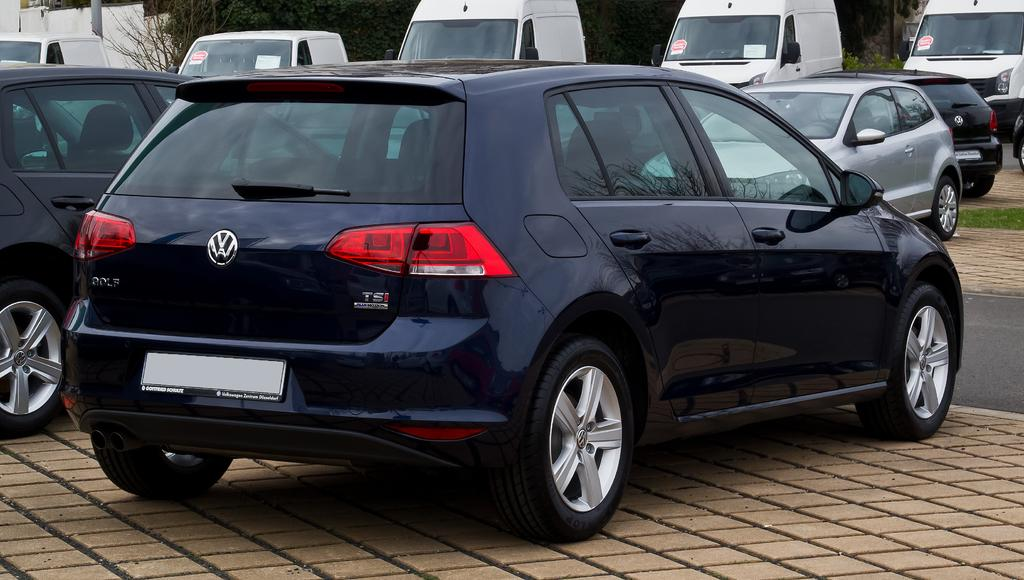What is the main subject of the image? The main subject of the image is many cars. Can you describe the position of a specific car in the image? A black car is parked on the pavement in the front. What can be seen on the right side of the image? There is a road on the right side of the image. What is visible in the background of the image? There are trees and a wall in the background of the image. What type of song is being played in the garden in the image? There is no garden or song present in the image; it features many cars, a black car, a road, trees, and a wall in the background. What color is the marble used for the flooring in the image? There is no marble flooring present in the image. 